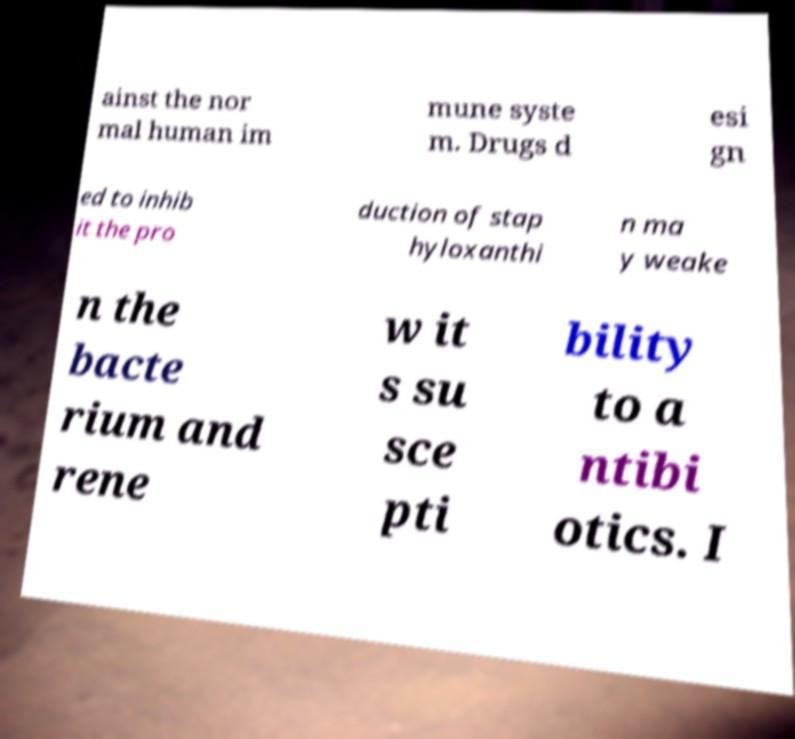For documentation purposes, I need the text within this image transcribed. Could you provide that? ainst the nor mal human im mune syste m. Drugs d esi gn ed to inhib it the pro duction of stap hyloxanthi n ma y weake n the bacte rium and rene w it s su sce pti bility to a ntibi otics. I 